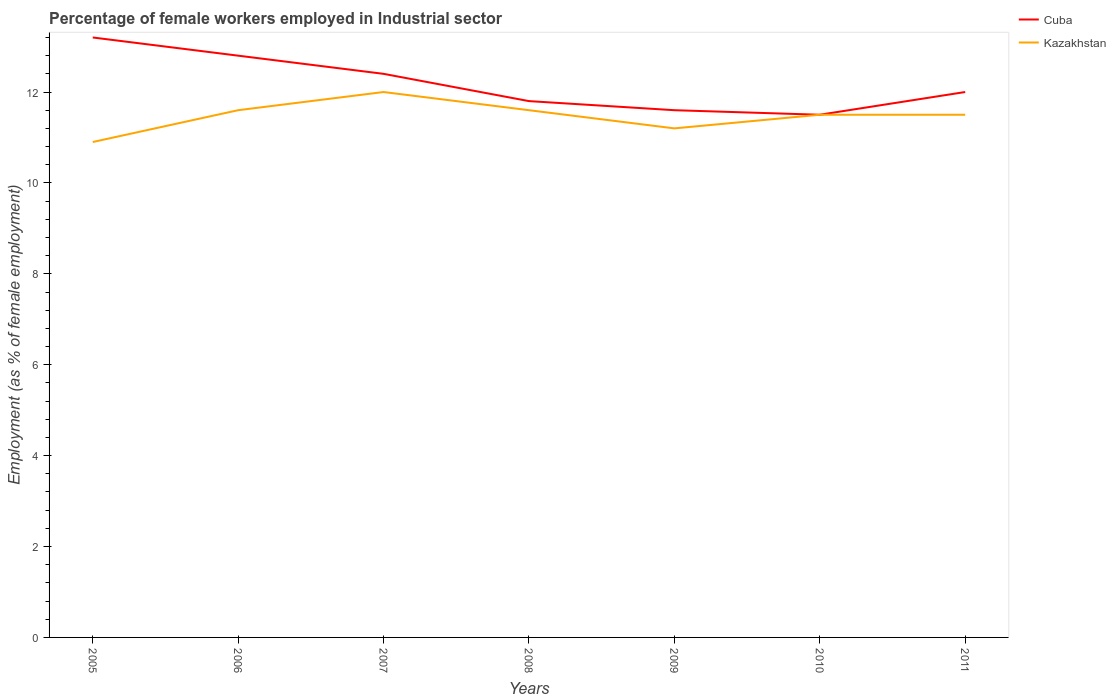Does the line corresponding to Kazakhstan intersect with the line corresponding to Cuba?
Your response must be concise. Yes. Is the number of lines equal to the number of legend labels?
Your answer should be compact. Yes. What is the total percentage of females employed in Industrial sector in Kazakhstan in the graph?
Provide a succinct answer. 0.4. What is the difference between the highest and the second highest percentage of females employed in Industrial sector in Kazakhstan?
Make the answer very short. 1.1. What is the difference between the highest and the lowest percentage of females employed in Industrial sector in Kazakhstan?
Provide a succinct answer. 5. Is the percentage of females employed in Industrial sector in Cuba strictly greater than the percentage of females employed in Industrial sector in Kazakhstan over the years?
Ensure brevity in your answer.  No. How many years are there in the graph?
Your answer should be compact. 7. Does the graph contain any zero values?
Your answer should be compact. No. Does the graph contain grids?
Your response must be concise. No. How many legend labels are there?
Provide a succinct answer. 2. What is the title of the graph?
Make the answer very short. Percentage of female workers employed in Industrial sector. Does "Albania" appear as one of the legend labels in the graph?
Offer a very short reply. No. What is the label or title of the X-axis?
Make the answer very short. Years. What is the label or title of the Y-axis?
Your answer should be very brief. Employment (as % of female employment). What is the Employment (as % of female employment) of Cuba in 2005?
Keep it short and to the point. 13.2. What is the Employment (as % of female employment) in Kazakhstan in 2005?
Ensure brevity in your answer.  10.9. What is the Employment (as % of female employment) of Cuba in 2006?
Give a very brief answer. 12.8. What is the Employment (as % of female employment) of Kazakhstan in 2006?
Offer a very short reply. 11.6. What is the Employment (as % of female employment) of Cuba in 2007?
Your answer should be compact. 12.4. What is the Employment (as % of female employment) of Kazakhstan in 2007?
Your answer should be compact. 12. What is the Employment (as % of female employment) in Cuba in 2008?
Your answer should be very brief. 11.8. What is the Employment (as % of female employment) in Kazakhstan in 2008?
Your response must be concise. 11.6. What is the Employment (as % of female employment) of Cuba in 2009?
Offer a terse response. 11.6. What is the Employment (as % of female employment) of Kazakhstan in 2009?
Ensure brevity in your answer.  11.2. What is the Employment (as % of female employment) of Cuba in 2010?
Provide a succinct answer. 11.5. What is the Employment (as % of female employment) in Kazakhstan in 2010?
Provide a succinct answer. 11.5. What is the Employment (as % of female employment) of Kazakhstan in 2011?
Your answer should be compact. 11.5. Across all years, what is the maximum Employment (as % of female employment) of Cuba?
Provide a succinct answer. 13.2. Across all years, what is the minimum Employment (as % of female employment) in Cuba?
Your answer should be compact. 11.5. Across all years, what is the minimum Employment (as % of female employment) in Kazakhstan?
Keep it short and to the point. 10.9. What is the total Employment (as % of female employment) of Cuba in the graph?
Offer a very short reply. 85.3. What is the total Employment (as % of female employment) in Kazakhstan in the graph?
Provide a short and direct response. 80.3. What is the difference between the Employment (as % of female employment) of Kazakhstan in 2005 and that in 2008?
Your response must be concise. -0.7. What is the difference between the Employment (as % of female employment) in Kazakhstan in 2005 and that in 2009?
Offer a very short reply. -0.3. What is the difference between the Employment (as % of female employment) of Kazakhstan in 2005 and that in 2010?
Offer a very short reply. -0.6. What is the difference between the Employment (as % of female employment) in Cuba in 2006 and that in 2008?
Your answer should be very brief. 1. What is the difference between the Employment (as % of female employment) in Cuba in 2006 and that in 2009?
Give a very brief answer. 1.2. What is the difference between the Employment (as % of female employment) in Kazakhstan in 2006 and that in 2010?
Keep it short and to the point. 0.1. What is the difference between the Employment (as % of female employment) of Cuba in 2006 and that in 2011?
Your answer should be very brief. 0.8. What is the difference between the Employment (as % of female employment) in Cuba in 2007 and that in 2008?
Give a very brief answer. 0.6. What is the difference between the Employment (as % of female employment) of Kazakhstan in 2007 and that in 2008?
Provide a short and direct response. 0.4. What is the difference between the Employment (as % of female employment) of Cuba in 2007 and that in 2010?
Provide a succinct answer. 0.9. What is the difference between the Employment (as % of female employment) in Kazakhstan in 2007 and that in 2010?
Provide a short and direct response. 0.5. What is the difference between the Employment (as % of female employment) of Cuba in 2007 and that in 2011?
Offer a very short reply. 0.4. What is the difference between the Employment (as % of female employment) in Kazakhstan in 2008 and that in 2009?
Provide a succinct answer. 0.4. What is the difference between the Employment (as % of female employment) of Cuba in 2008 and that in 2010?
Your response must be concise. 0.3. What is the difference between the Employment (as % of female employment) of Kazakhstan in 2008 and that in 2011?
Your response must be concise. 0.1. What is the difference between the Employment (as % of female employment) in Kazakhstan in 2010 and that in 2011?
Offer a very short reply. 0. What is the difference between the Employment (as % of female employment) of Cuba in 2005 and the Employment (as % of female employment) of Kazakhstan in 2006?
Ensure brevity in your answer.  1.6. What is the difference between the Employment (as % of female employment) of Cuba in 2005 and the Employment (as % of female employment) of Kazakhstan in 2011?
Provide a succinct answer. 1.7. What is the difference between the Employment (as % of female employment) of Cuba in 2006 and the Employment (as % of female employment) of Kazakhstan in 2008?
Provide a succinct answer. 1.2. What is the difference between the Employment (as % of female employment) in Cuba in 2006 and the Employment (as % of female employment) in Kazakhstan in 2009?
Your answer should be compact. 1.6. What is the difference between the Employment (as % of female employment) in Cuba in 2006 and the Employment (as % of female employment) in Kazakhstan in 2010?
Keep it short and to the point. 1.3. What is the difference between the Employment (as % of female employment) in Cuba in 2007 and the Employment (as % of female employment) in Kazakhstan in 2008?
Ensure brevity in your answer.  0.8. What is the difference between the Employment (as % of female employment) in Cuba in 2008 and the Employment (as % of female employment) in Kazakhstan in 2009?
Your answer should be compact. 0.6. What is the difference between the Employment (as % of female employment) in Cuba in 2008 and the Employment (as % of female employment) in Kazakhstan in 2010?
Provide a succinct answer. 0.3. What is the difference between the Employment (as % of female employment) in Cuba in 2008 and the Employment (as % of female employment) in Kazakhstan in 2011?
Make the answer very short. 0.3. What is the difference between the Employment (as % of female employment) of Cuba in 2009 and the Employment (as % of female employment) of Kazakhstan in 2011?
Your answer should be very brief. 0.1. What is the average Employment (as % of female employment) of Cuba per year?
Provide a short and direct response. 12.19. What is the average Employment (as % of female employment) in Kazakhstan per year?
Your answer should be very brief. 11.47. In the year 2007, what is the difference between the Employment (as % of female employment) in Cuba and Employment (as % of female employment) in Kazakhstan?
Provide a short and direct response. 0.4. In the year 2010, what is the difference between the Employment (as % of female employment) of Cuba and Employment (as % of female employment) of Kazakhstan?
Offer a terse response. 0. In the year 2011, what is the difference between the Employment (as % of female employment) in Cuba and Employment (as % of female employment) in Kazakhstan?
Make the answer very short. 0.5. What is the ratio of the Employment (as % of female employment) in Cuba in 2005 to that in 2006?
Make the answer very short. 1.03. What is the ratio of the Employment (as % of female employment) in Kazakhstan in 2005 to that in 2006?
Provide a succinct answer. 0.94. What is the ratio of the Employment (as % of female employment) of Cuba in 2005 to that in 2007?
Give a very brief answer. 1.06. What is the ratio of the Employment (as % of female employment) in Kazakhstan in 2005 to that in 2007?
Make the answer very short. 0.91. What is the ratio of the Employment (as % of female employment) of Cuba in 2005 to that in 2008?
Ensure brevity in your answer.  1.12. What is the ratio of the Employment (as % of female employment) in Kazakhstan in 2005 to that in 2008?
Ensure brevity in your answer.  0.94. What is the ratio of the Employment (as % of female employment) in Cuba in 2005 to that in 2009?
Offer a very short reply. 1.14. What is the ratio of the Employment (as % of female employment) in Kazakhstan in 2005 to that in 2009?
Ensure brevity in your answer.  0.97. What is the ratio of the Employment (as % of female employment) in Cuba in 2005 to that in 2010?
Your response must be concise. 1.15. What is the ratio of the Employment (as % of female employment) of Kazakhstan in 2005 to that in 2010?
Your answer should be very brief. 0.95. What is the ratio of the Employment (as % of female employment) of Cuba in 2005 to that in 2011?
Offer a very short reply. 1.1. What is the ratio of the Employment (as % of female employment) in Kazakhstan in 2005 to that in 2011?
Your answer should be compact. 0.95. What is the ratio of the Employment (as % of female employment) in Cuba in 2006 to that in 2007?
Ensure brevity in your answer.  1.03. What is the ratio of the Employment (as % of female employment) of Kazakhstan in 2006 to that in 2007?
Provide a short and direct response. 0.97. What is the ratio of the Employment (as % of female employment) of Cuba in 2006 to that in 2008?
Offer a terse response. 1.08. What is the ratio of the Employment (as % of female employment) of Cuba in 2006 to that in 2009?
Make the answer very short. 1.1. What is the ratio of the Employment (as % of female employment) in Kazakhstan in 2006 to that in 2009?
Give a very brief answer. 1.04. What is the ratio of the Employment (as % of female employment) in Cuba in 2006 to that in 2010?
Provide a short and direct response. 1.11. What is the ratio of the Employment (as % of female employment) of Kazakhstan in 2006 to that in 2010?
Provide a short and direct response. 1.01. What is the ratio of the Employment (as % of female employment) in Cuba in 2006 to that in 2011?
Your answer should be very brief. 1.07. What is the ratio of the Employment (as % of female employment) of Kazakhstan in 2006 to that in 2011?
Your response must be concise. 1.01. What is the ratio of the Employment (as % of female employment) of Cuba in 2007 to that in 2008?
Ensure brevity in your answer.  1.05. What is the ratio of the Employment (as % of female employment) of Kazakhstan in 2007 to that in 2008?
Make the answer very short. 1.03. What is the ratio of the Employment (as % of female employment) of Cuba in 2007 to that in 2009?
Your response must be concise. 1.07. What is the ratio of the Employment (as % of female employment) of Kazakhstan in 2007 to that in 2009?
Your response must be concise. 1.07. What is the ratio of the Employment (as % of female employment) of Cuba in 2007 to that in 2010?
Give a very brief answer. 1.08. What is the ratio of the Employment (as % of female employment) in Kazakhstan in 2007 to that in 2010?
Offer a very short reply. 1.04. What is the ratio of the Employment (as % of female employment) of Kazakhstan in 2007 to that in 2011?
Make the answer very short. 1.04. What is the ratio of the Employment (as % of female employment) of Cuba in 2008 to that in 2009?
Provide a succinct answer. 1.02. What is the ratio of the Employment (as % of female employment) in Kazakhstan in 2008 to that in 2009?
Your answer should be compact. 1.04. What is the ratio of the Employment (as % of female employment) in Cuba in 2008 to that in 2010?
Your answer should be compact. 1.03. What is the ratio of the Employment (as % of female employment) in Kazakhstan in 2008 to that in 2010?
Keep it short and to the point. 1.01. What is the ratio of the Employment (as % of female employment) in Cuba in 2008 to that in 2011?
Provide a short and direct response. 0.98. What is the ratio of the Employment (as % of female employment) of Kazakhstan in 2008 to that in 2011?
Your response must be concise. 1.01. What is the ratio of the Employment (as % of female employment) of Cuba in 2009 to that in 2010?
Offer a terse response. 1.01. What is the ratio of the Employment (as % of female employment) of Kazakhstan in 2009 to that in 2010?
Provide a succinct answer. 0.97. What is the ratio of the Employment (as % of female employment) in Cuba in 2009 to that in 2011?
Provide a short and direct response. 0.97. What is the ratio of the Employment (as % of female employment) in Kazakhstan in 2009 to that in 2011?
Offer a very short reply. 0.97. What is the ratio of the Employment (as % of female employment) of Kazakhstan in 2010 to that in 2011?
Your answer should be very brief. 1. What is the difference between the highest and the second highest Employment (as % of female employment) of Cuba?
Your answer should be very brief. 0.4. What is the difference between the highest and the lowest Employment (as % of female employment) of Cuba?
Keep it short and to the point. 1.7. What is the difference between the highest and the lowest Employment (as % of female employment) of Kazakhstan?
Offer a terse response. 1.1. 